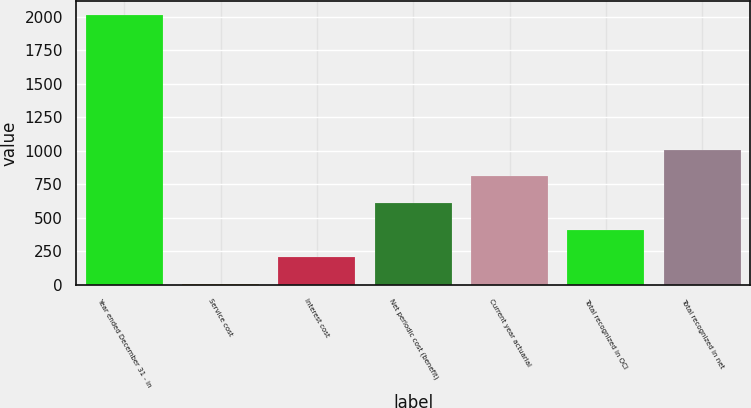Convert chart to OTSL. <chart><loc_0><loc_0><loc_500><loc_500><bar_chart><fcel>Year ended December 31 - in<fcel>Service cost<fcel>Interest cost<fcel>Net periodic cost (benefit)<fcel>Current year actuarial<fcel>Total recognized in OCI<fcel>Total recognized in net<nl><fcel>2012<fcel>4<fcel>204.8<fcel>606.4<fcel>807.2<fcel>405.6<fcel>1008<nl></chart> 